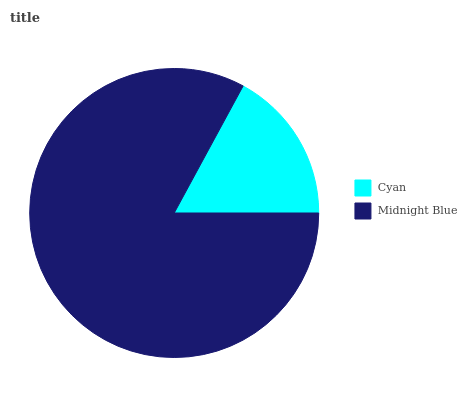Is Cyan the minimum?
Answer yes or no. Yes. Is Midnight Blue the maximum?
Answer yes or no. Yes. Is Midnight Blue the minimum?
Answer yes or no. No. Is Midnight Blue greater than Cyan?
Answer yes or no. Yes. Is Cyan less than Midnight Blue?
Answer yes or no. Yes. Is Cyan greater than Midnight Blue?
Answer yes or no. No. Is Midnight Blue less than Cyan?
Answer yes or no. No. Is Midnight Blue the high median?
Answer yes or no. Yes. Is Cyan the low median?
Answer yes or no. Yes. Is Cyan the high median?
Answer yes or no. No. Is Midnight Blue the low median?
Answer yes or no. No. 